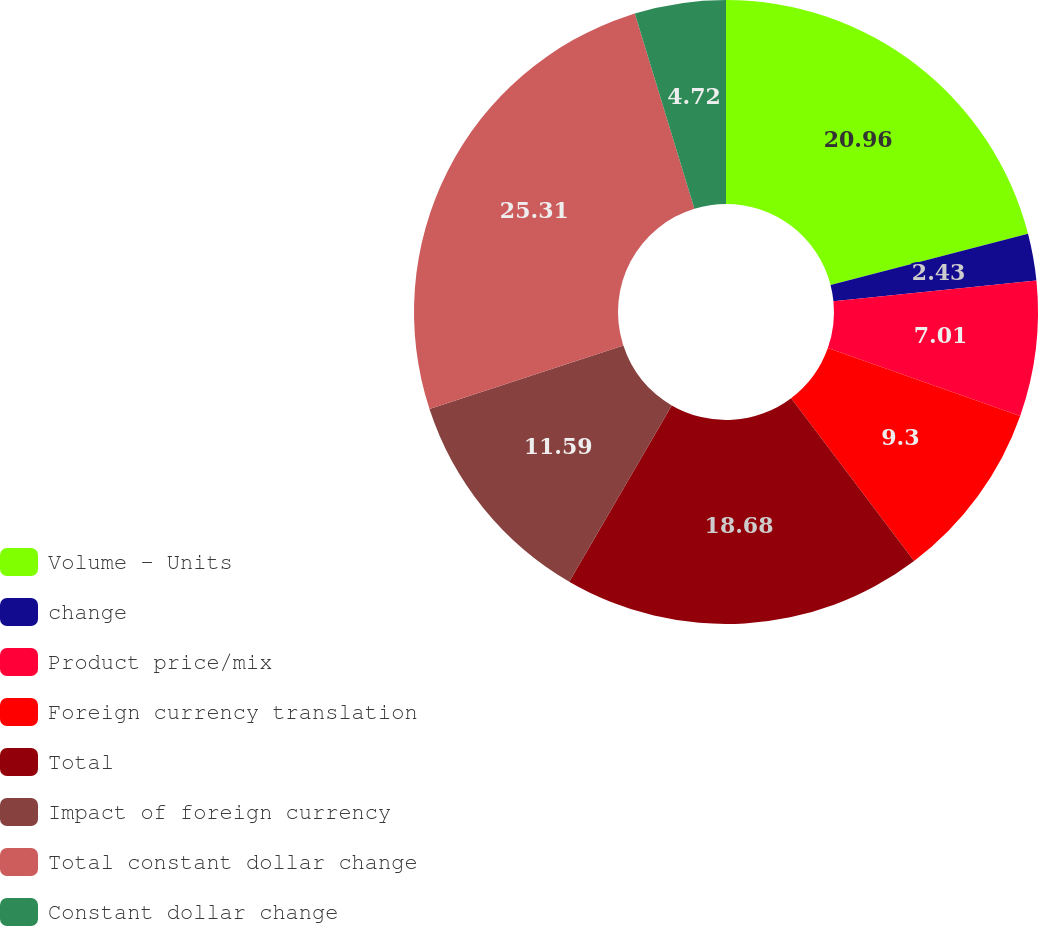<chart> <loc_0><loc_0><loc_500><loc_500><pie_chart><fcel>Volume - Units<fcel>change<fcel>Product price/mix<fcel>Foreign currency translation<fcel>Total<fcel>Impact of foreign currency<fcel>Total constant dollar change<fcel>Constant dollar change<nl><fcel>20.97%<fcel>2.43%<fcel>7.01%<fcel>9.3%<fcel>18.68%<fcel>11.59%<fcel>25.32%<fcel>4.72%<nl></chart> 